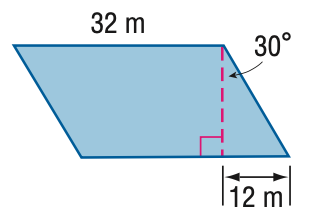Answer the mathemtical geometry problem and directly provide the correct option letter.
Question: Find the area of the parallelogram. Round to the nearest tenth if necessary.
Choices: A: 332.6 B: 543.1 C: 665.1 D: 768 C 